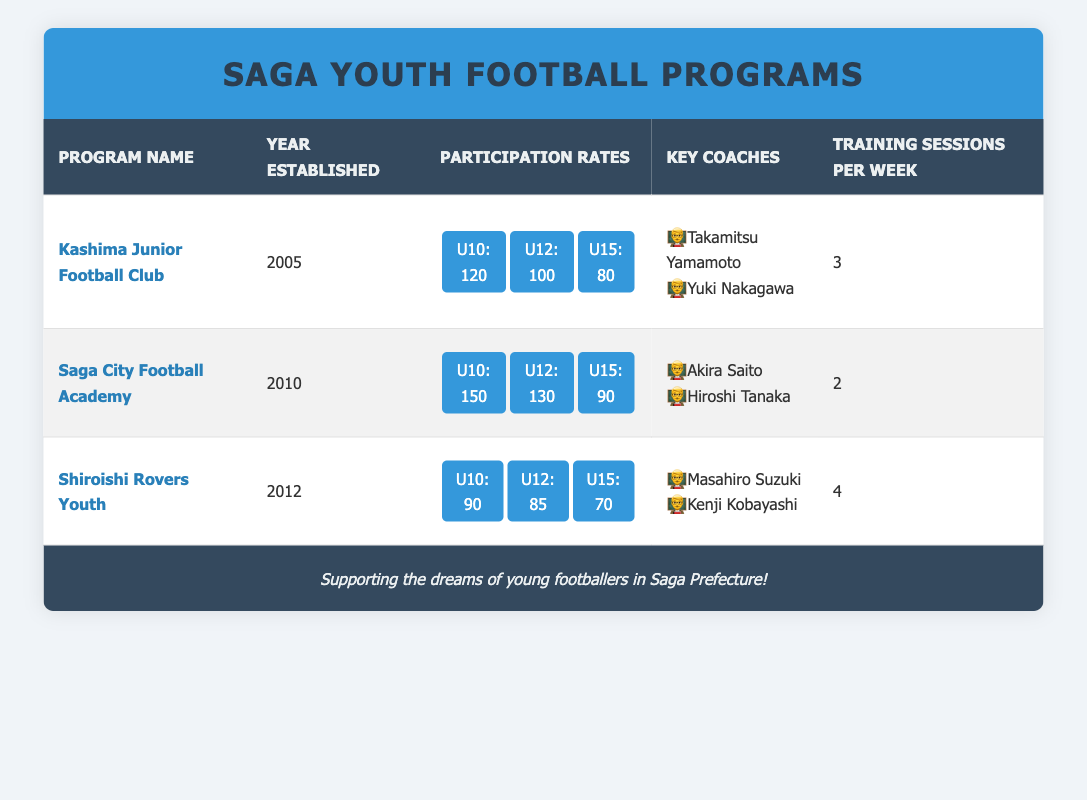What year was the Kashima Junior Football Club established? The table shows that the Kashima Junior Football Club was established in 2005.
Answer: 2005 How many key coaches are associated with the Saga City Football Academy? The table lists two key coaches for the Saga City Football Academy: Akira Saito and Hiroshi Tanaka.
Answer: 2 What is the total participation for U10 across all programs? The U10 participation rates are 120 for Kashima Junior Football Club, 150 for Saga City Football Academy, and 90 for Shiroishi Rovers Youth. Adding these gives 120 + 150 + 90 = 360.
Answer: 360 Which program has the highest participation rate for U12? Referencing the U12 participation rates, Kashima Junior Football Club has 100, Saga City Football Academy has 130, and Shiroishi Rovers Youth has 85. Saga City Football Academy has the highest at 130.
Answer: Saga City Football Academy Is the total participation for U15 in the Shiroishi Rovers Youth more than in the Kashima Junior Football Club? The U15 participation for Shiroishi Rovers Youth is 70, while for Kashima Junior Football Club it is 80. Since 70 is less than 80, the statement is false.
Answer: No What is the average number of training sessions per week across all programs? The table shows that training sessions per week are 3 for Kashima Junior Football Club, 2 for Saga City Football Academy, and 4 for Shiroishi Rovers Youth. The total is 3 + 2 + 4 = 9, and there are 3 programs, so the average is 9 / 3 = 3.
Answer: 3 Which program has the least U15 participation? The U15 participation rates are 80 for Kashima Junior Football Club, 90 for Saga City Football Academy, and 70 for Shiroishi Rovers Youth. Thus, Shiroishi Rovers Youth has the least U15 participation at 70.
Answer: Shiroishi Rovers Youth Are there any programs with 4 training sessions per week? The table indicates that only Shiroishi Rovers Youth has 4 training sessions per week. Thus, the answer is yes.
Answer: Yes 